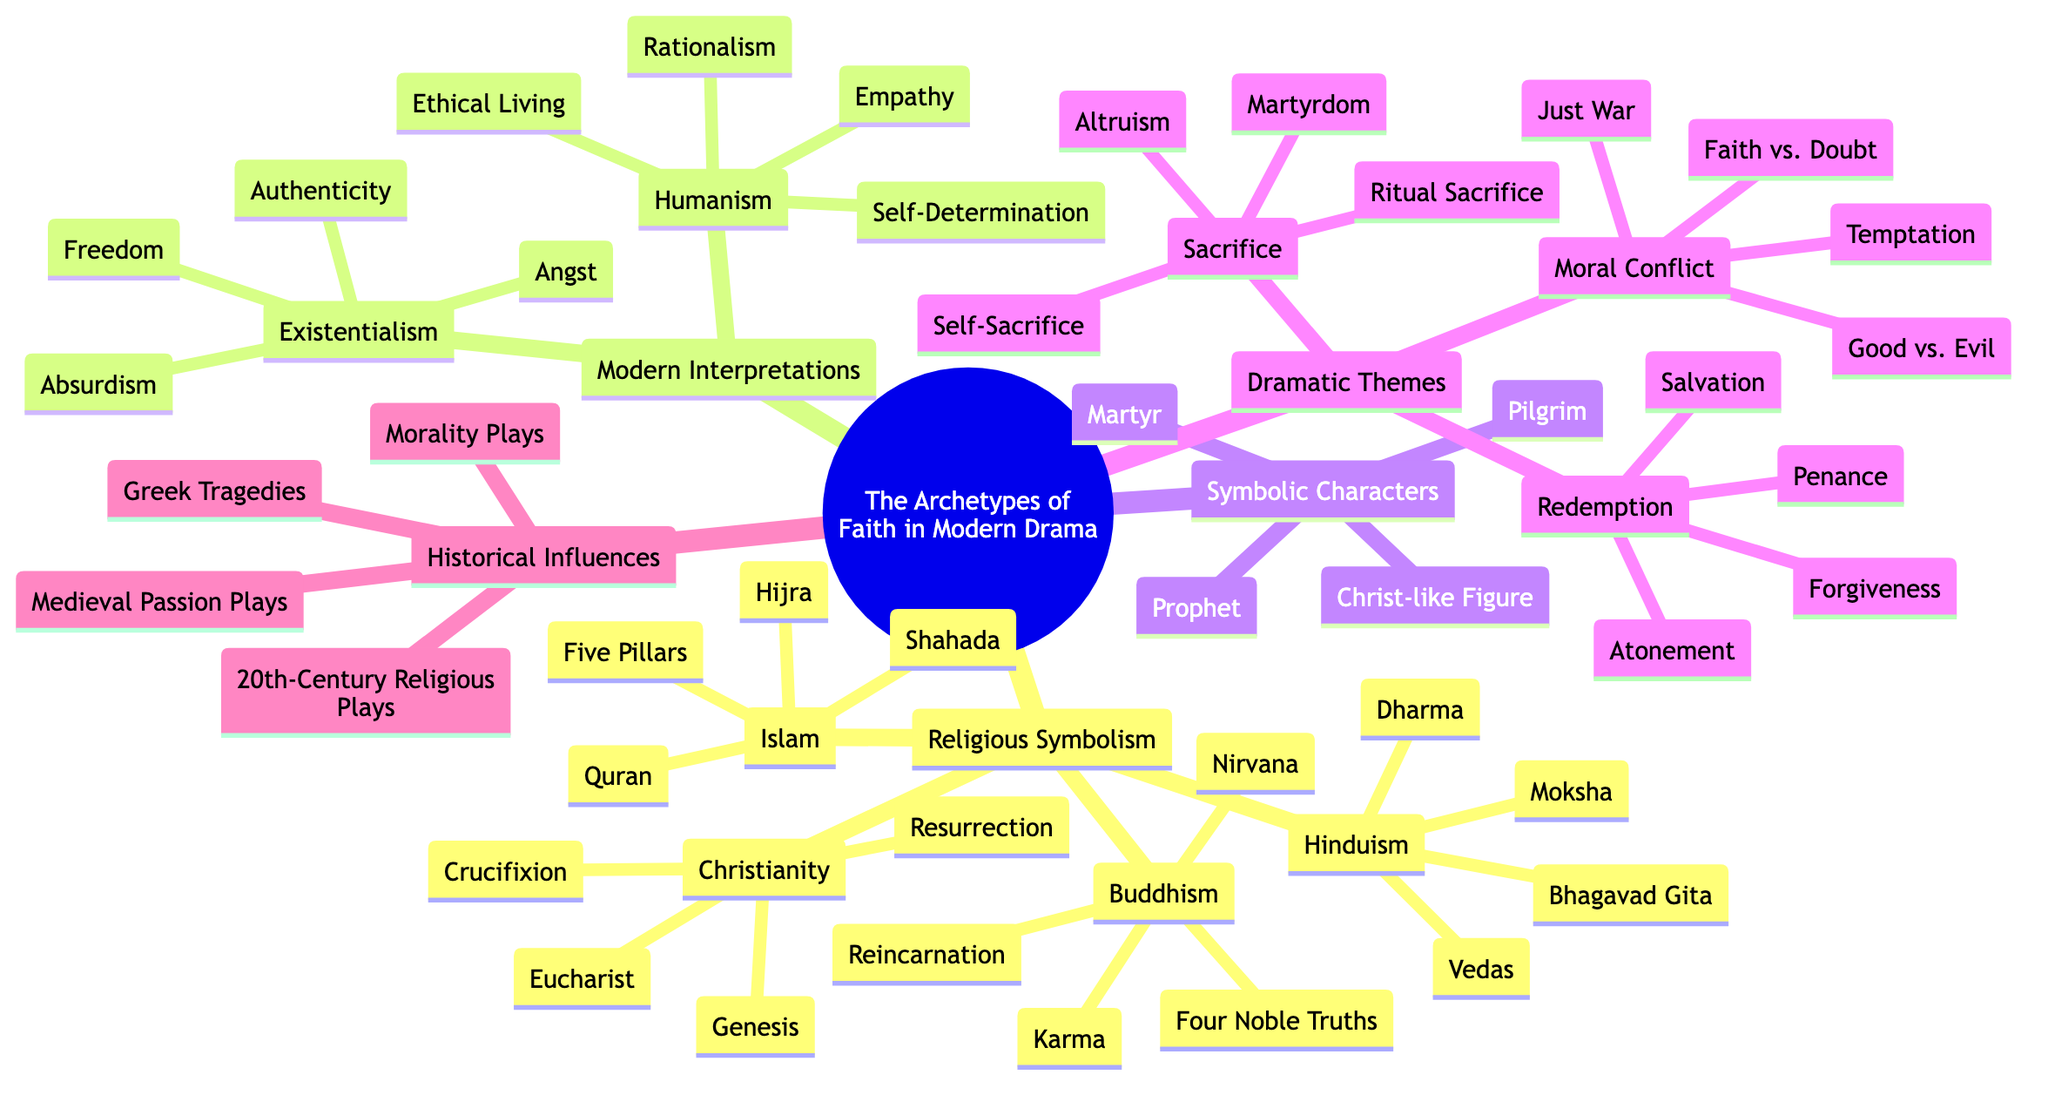What are the elements under Christianity? The branch "Christianity" lists the elements "Crucifixion", "Resurrection", "Eucharist", and "Genesis". Each of these elements represents significant aspects of the Christian faith.
Answer: Crucifixion, Resurrection, Eucharist, Genesis How many elements are in the Symbolic Characters section? The "Symbolic Characters" section contains four elements: "Christ-like Figure", "Prophet", "Martyr", and "Pilgrim". Counting these gives a total of four.
Answer: 4 Which dramatic theme includes Atonement? The element "Atonement" is included under the "Redemption" theme, which discusses various aspects related to redemption in literature.
Answer: Redemption What are the four Noble Truths associated with? The "Four Noble Truths" are associated with "Buddhism", one of the branches under "Religious Symbolism". This links to the core principles of Buddhist belief.
Answer: Buddhism Which branch contains the element 'Self-Determination'? The element "Self-Determination" is found under the "Humanism" sub-branch within the "Modern Interpretations" branch, highlighting a key tenet of humanist philosophy.
Answer: Humanism What historical influence involves Medieval Passion Plays? The element "Medieval Passion Plays" is listed under "Historical Influences". This indicates a significant form of drama that draws on religious themes, specifically in the context of the Middle Ages.
Answer: Historical Influences How many sub-branches are under Modern Interpretations? The "Modern Interpretations" branch has two sub-branches: "Existentialism" and "Humanism". This indicates the growing intellectual movements regarding faith in the modern context.
Answer: 2 Which dramatic theme has elements related to moral dilemmas? The theme related to moral dilemmas is "Moral Conflict", which includes elements like "Good vs. Evil" and "Faith vs. Doubt". This theme explores the challenges of faith amidst conflicting moral choices.
Answer: Moral Conflict What religious concept does the element 'Nirvana' belong to? The element "Nirvana" belongs to the sub-branch "Buddhism" within the "Religious Symbolism" branch. It represents a key goal in Buddhist practice, emphasizing enlightenment and liberation.
Answer: Buddhism 